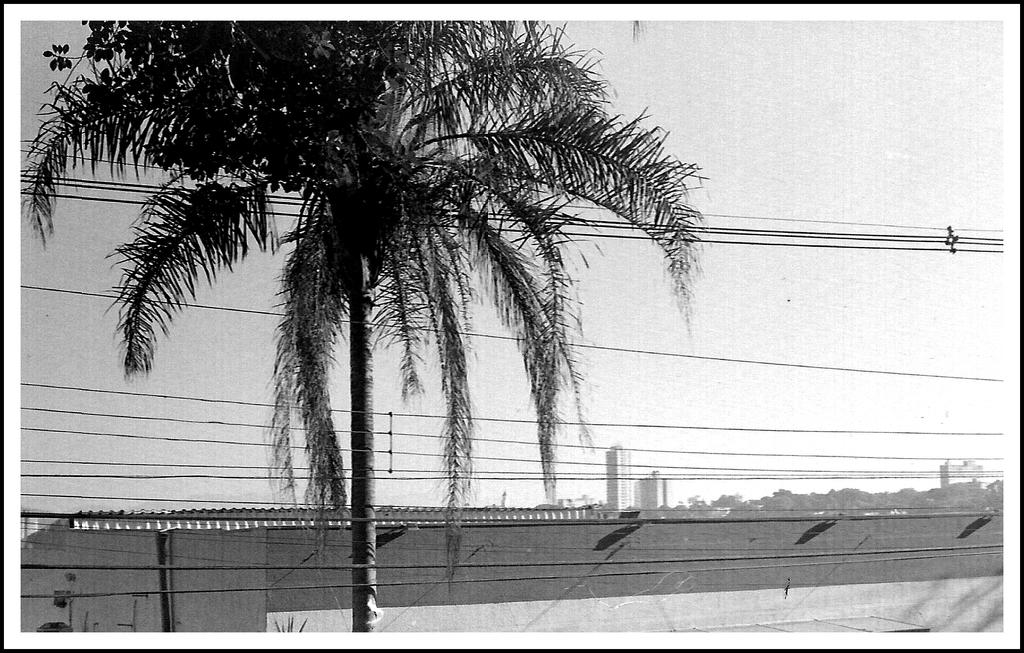What is the color scheme of the image? The image is black and white. What natural element can be seen in the image? There is a tree in the image. What man-made structures are present in the image? There are electric wires, a house, pipes, and buildings visible in the image. What can be seen in the background of the image? There are trees, buildings, and the sky visible in the background of the image. What type of button can be seen on the tree in the image? There is no button present on the tree in the image. How does the acoustics of the image affect the sound quality of the scene? The image is a still image and does not have any sound or acoustics. Is there a camp visible in the image? There is no camp present in the image. 